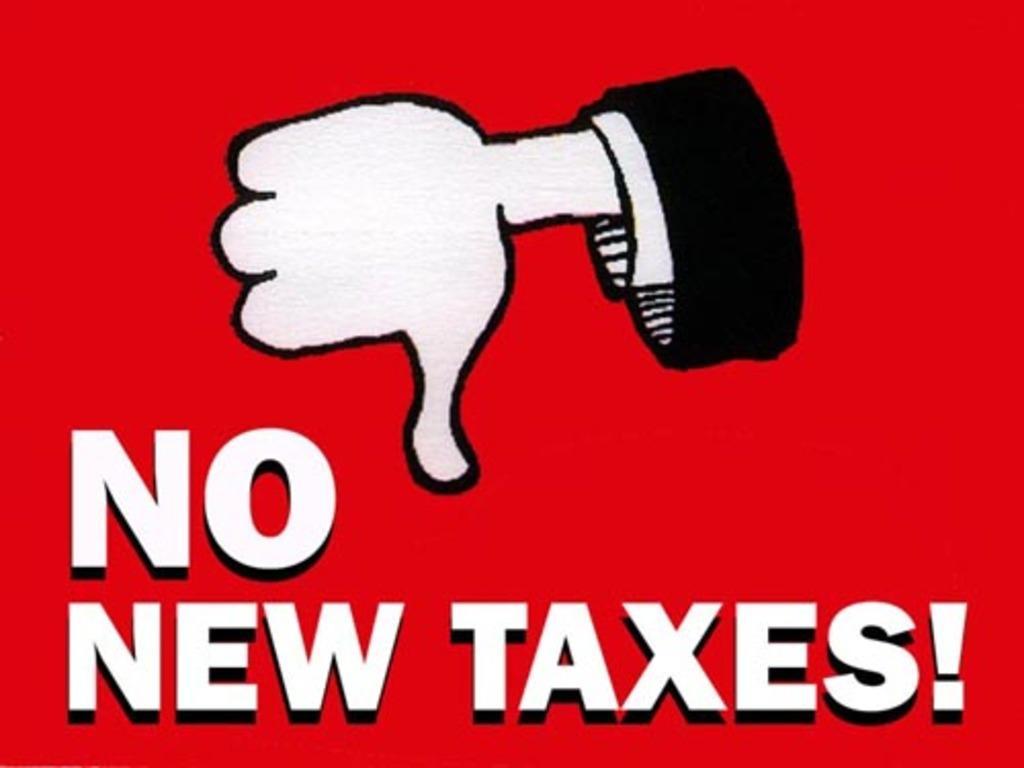How would you summarize this image in a sentence or two? This image contains a poster having some text and painting. Top of the image there is a painting of a person's hand. Bottom of the image there is some text. Background is in red color. 